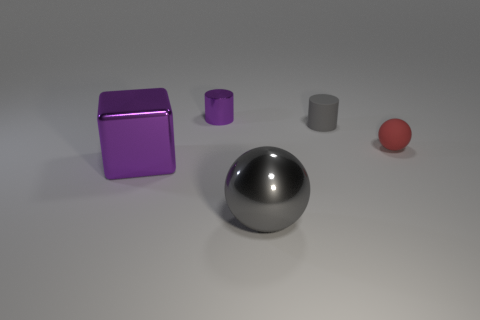What number of objects are both on the left side of the big gray metallic thing and behind the red rubber ball?
Ensure brevity in your answer.  1. Is there anything else that is the same shape as the large purple shiny object?
Offer a very short reply. No. There is a ball that is in front of the red rubber ball; how big is it?
Keep it short and to the point. Large. How many other things are there of the same color as the small matte cylinder?
Provide a short and direct response. 1. What is the small object that is right of the gray thing behind the gray metallic thing made of?
Offer a very short reply. Rubber. Does the rubber thing that is in front of the tiny gray thing have the same color as the small shiny cylinder?
Provide a short and direct response. No. What number of other gray metal objects are the same shape as the small metallic object?
Your answer should be very brief. 0. What is the size of the purple cylinder that is the same material as the big purple object?
Your answer should be compact. Small. There is a object behind the small rubber thing left of the red matte object; is there a purple shiny cube that is on the left side of it?
Offer a terse response. Yes. There is a purple thing that is behind the purple shiny block; is its size the same as the small ball?
Provide a succinct answer. Yes. 